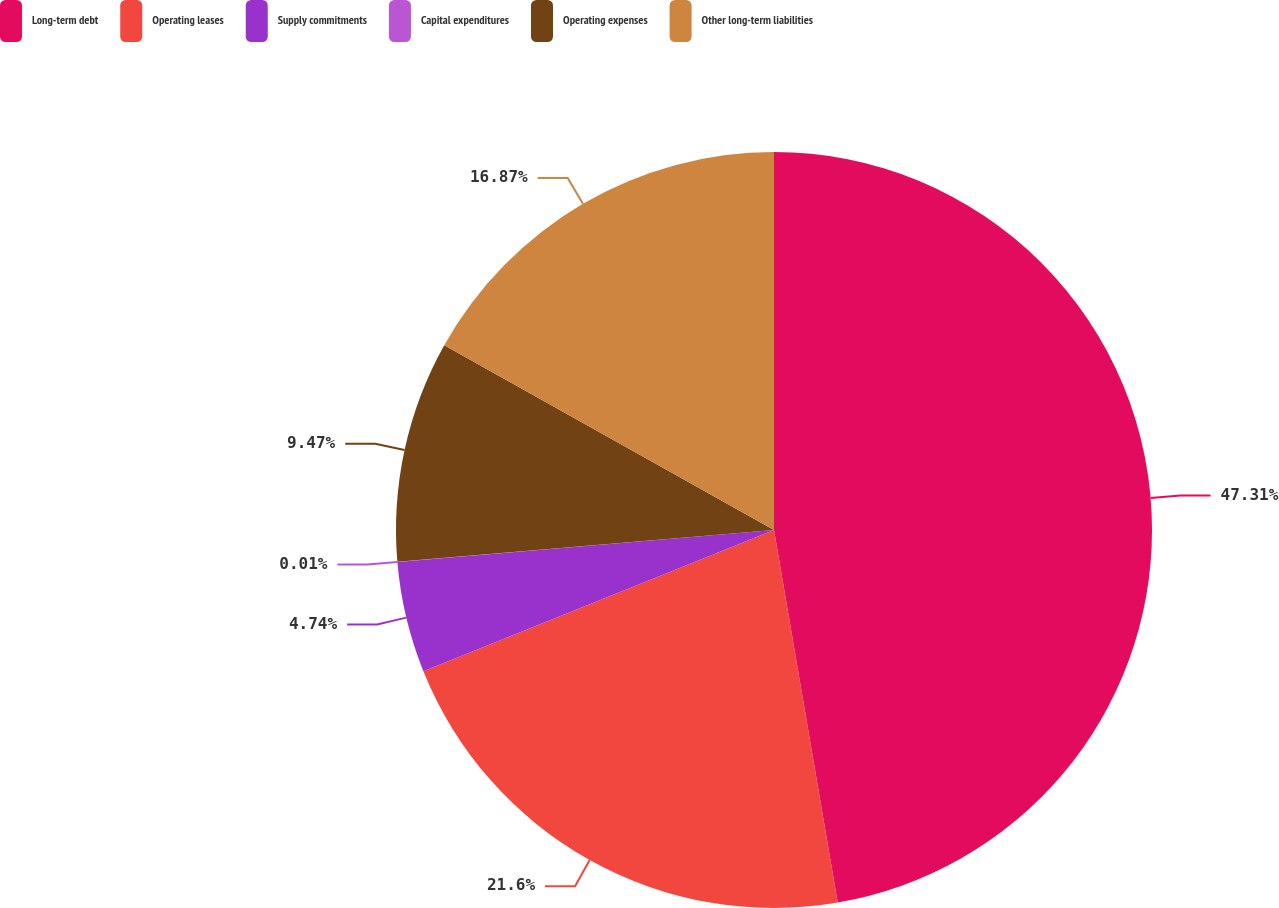Convert chart to OTSL. <chart><loc_0><loc_0><loc_500><loc_500><pie_chart><fcel>Long-term debt<fcel>Operating leases<fcel>Supply commitments<fcel>Capital expenditures<fcel>Operating expenses<fcel>Other long-term liabilities<nl><fcel>47.3%<fcel>21.6%<fcel>4.74%<fcel>0.01%<fcel>9.47%<fcel>16.87%<nl></chart> 